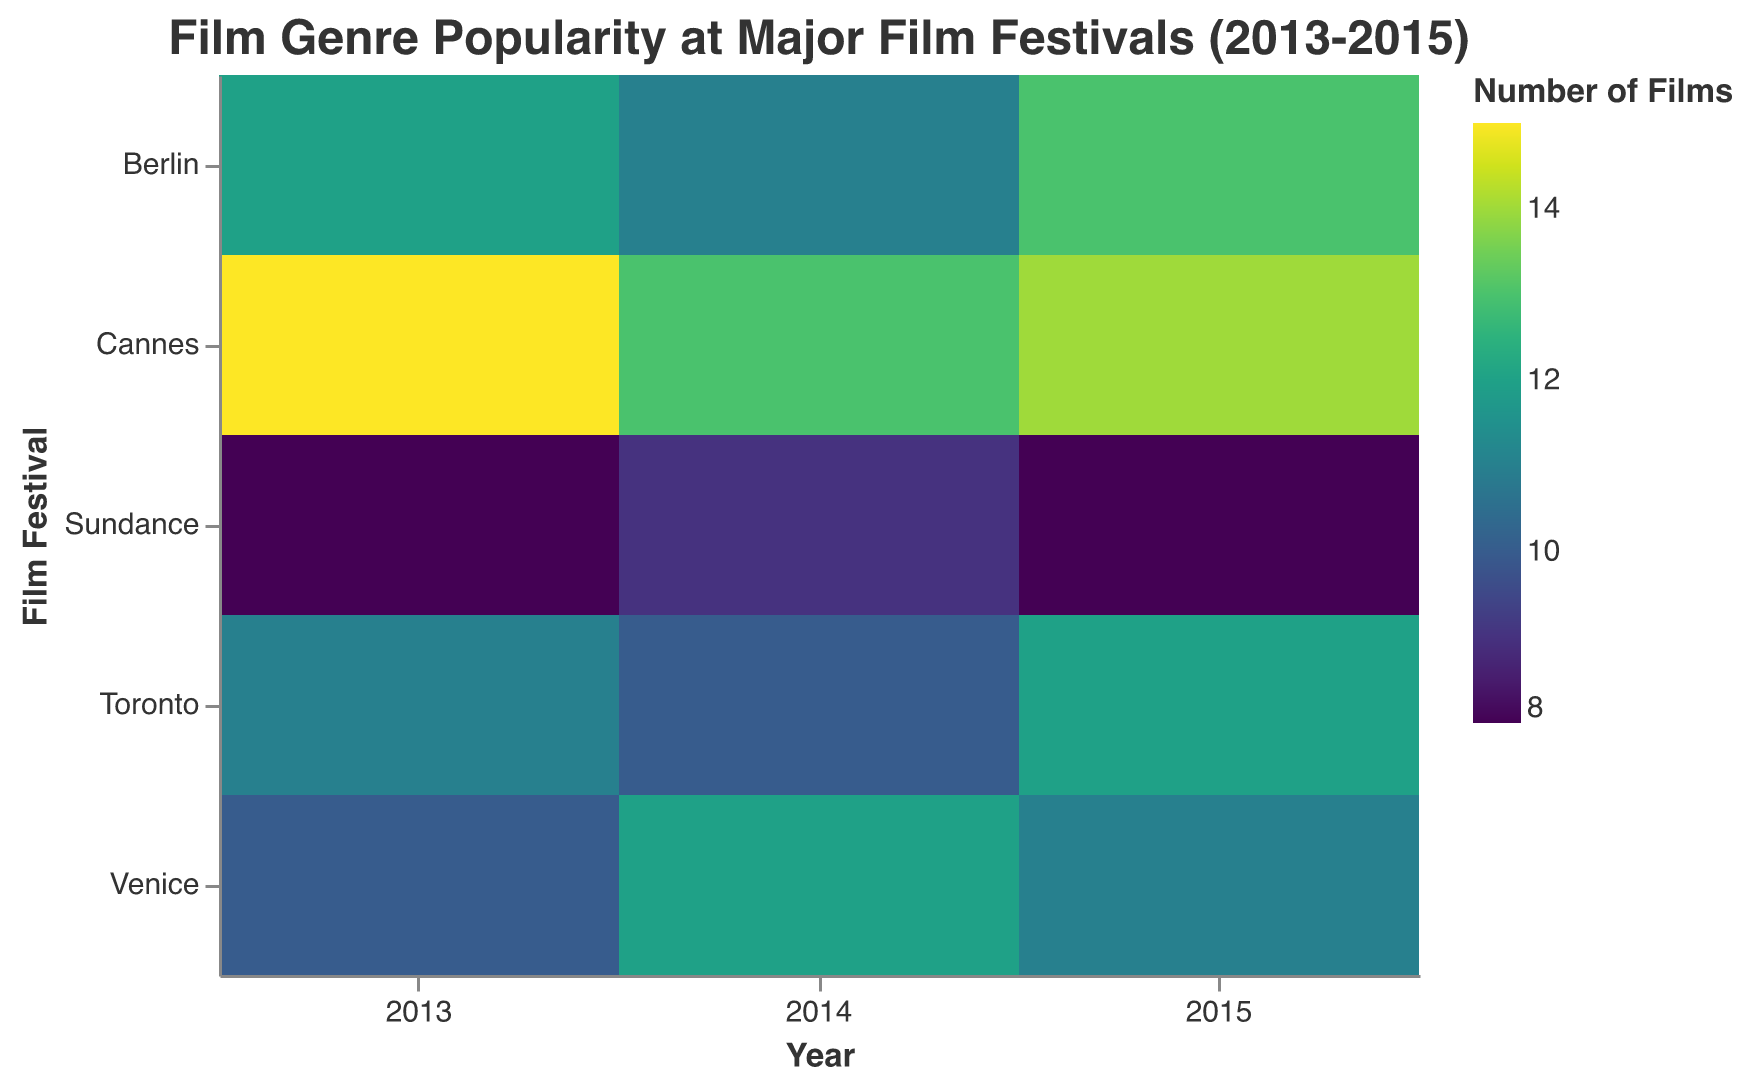What's the title of the heatmap? The title is displayed at the top of the heatmap in a larger font size. It reads "Film Genre Popularity at Major Film Festivals (2013-2015)" as seen at the top center of the figure.
Answer: Film Genre Popularity at Major Film Festivals (2013-2015) What are the x-axis and y-axis representing? On the x-axis, we can see the label "Year", indicating that it represents different years from 2013 to 2015. The y-axis is labeled "Film Festival", signifying different film festivals such as Cannes, Berlin, Venice, Sundance, and Toronto.
Answer: The x-axis represents the years, and the y-axis represents the film festivals Which film festival had the highest number of drama films in 2013? Locating the row labeled "Cannes" and the column labeled "2013", the color intensity is the highest in this combination compared to other film festivals in 2013, indicating a higher number of drama films.
Answer: Cannes How did the number of comedy films at Toronto change from 2013 to 2015? Observing the color gradients for Toronto in the comedy category shows a moderate value in 2013, slightly less intense in 2014, and higher intensity in 2015, indicating it increased over time.
Answer: Increased What is the trend for horror films in Sundance from 2013 to 2015? Reviewing the color gradient for Sundance in the horror category, the color is faint in 2013, maintains a similar faintness in 2014, but slightly more intense in 2015, showing a slight increase.
Answer: Slight increase Which genre has the lowest overall representation at Berlin in 2015? Checking the color intensity for Berlin in 2015 across all genres, the lightest color appears in the romance category, indicating it has the lowest representation.
Answer: Romance Is the number of documentary films higher in Cannes or Venice in 2014? By comparing the color gradients for the documentary category in 2014 for Cannes and Venice, it's evident that Cannes has a slightly darker shade than Venice, indicating more documentary films in Cannes.
Answer: Cannes What is the average number of drama films across all festivals in 2014? Summing up the drama entries in 2014 for each festival (13 + 11 + 12 + 9 + 10 = 55) and dividing by the number of festivals (5) gives us 55/5.
Answer: 11 How do thriller films compare between Cannes and Toronto in 2014? Comparing the color intensities for the thriller genre between Cannes and Toronto in 2014, Toronto has a darker shade, indicating more thriller films.
Answer: More in Toronto Which film festival consistently had the most films in the romance genre from 2013 to 2015? Checking the romance column for each year, Berlin, with consistently moderate shades, has higher numbers compared to other festivals, especially evident in the relatively even intensity across all years.
Answer: Berlin 